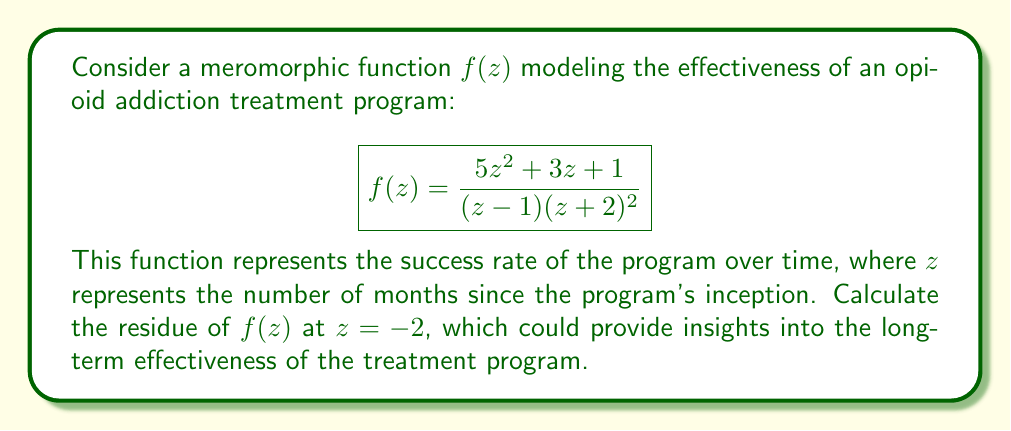Help me with this question. To calculate the residue of $f(z)$ at $z = -2$, we need to determine the order of the pole at this point and use the appropriate method.

1) First, we observe that $z = -2$ is a pole of order 2 (double pole) for $f(z)$.

2) For a pole of order 2, we can use the formula:

   $$\text{Res}(f, -2) = \lim_{z \to -2} \frac{d}{dz}\left[(z+2)^2f(z)\right]$$

3) Let's define $g(z) = (z+2)^2f(z)$:

   $$g(z) = (z+2)^2 \cdot \frac{5z^2 + 3z + 1}{(z - 1)(z + 2)^2} = \frac{5z^2 + 3z + 1}{z - 1}$$

4) Now we need to differentiate $g(z)$:

   $$g'(z) = \frac{(10z + 3)(z - 1) - (5z^2 + 3z + 1)}{(z - 1)^2}$$

5) Simplify the numerator:

   $$g'(z) = \frac{10z^2 + 3z - 10z - 3 - 5z^2 - 3z - 1}{(z - 1)^2} = \frac{5z^2 - 13z - 4}{(z - 1)^2}$$

6) Now we evaluate this at $z = -2$:

   $$\text{Res}(f, -2) = g'(-2) = \frac{5(-2)^2 - 13(-2) - 4}{(-2 - 1)^2} = \frac{20 + 26 - 4}{9} = \frac{42}{9}$$

Therefore, the residue of $f(z)$ at $z = -2$ is $\frac{42}{9}$.
Answer: $\frac{42}{9}$ 